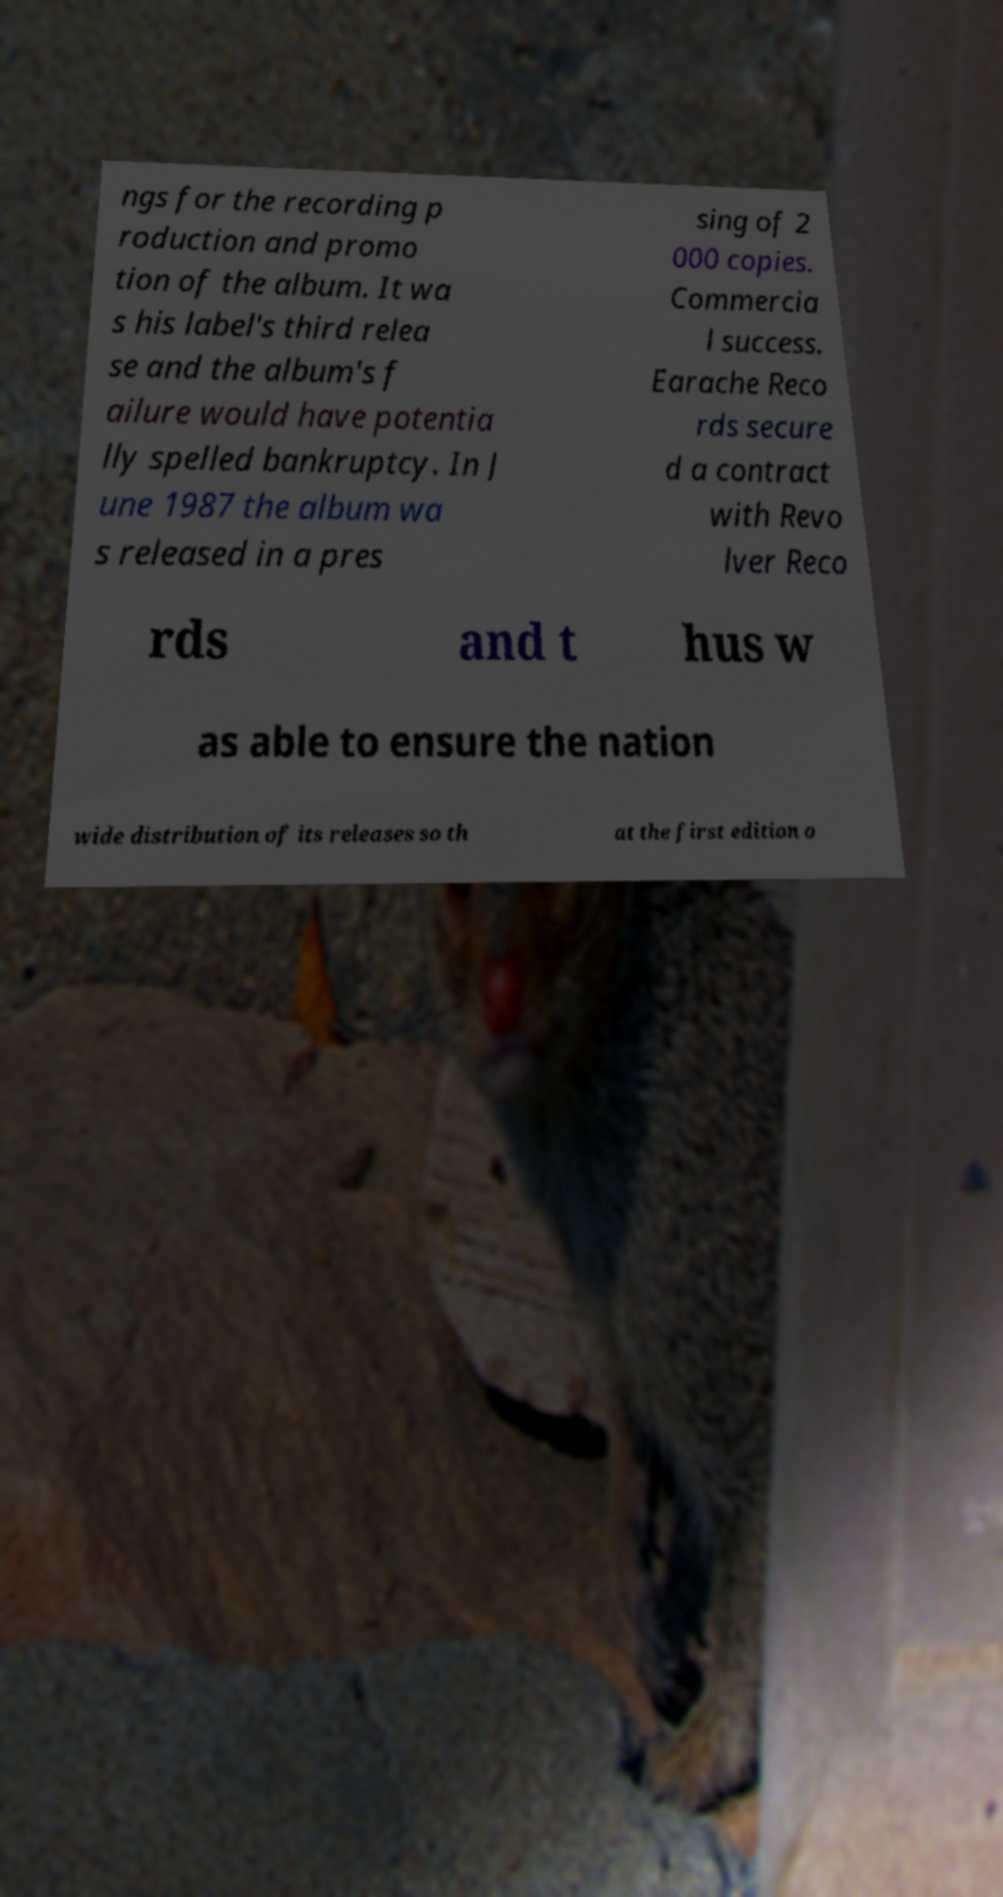Can you accurately transcribe the text from the provided image for me? ngs for the recording p roduction and promo tion of the album. It wa s his label's third relea se and the album's f ailure would have potentia lly spelled bankruptcy. In J une 1987 the album wa s released in a pres sing of 2 000 copies. Commercia l success. Earache Reco rds secure d a contract with Revo lver Reco rds and t hus w as able to ensure the nation wide distribution of its releases so th at the first edition o 